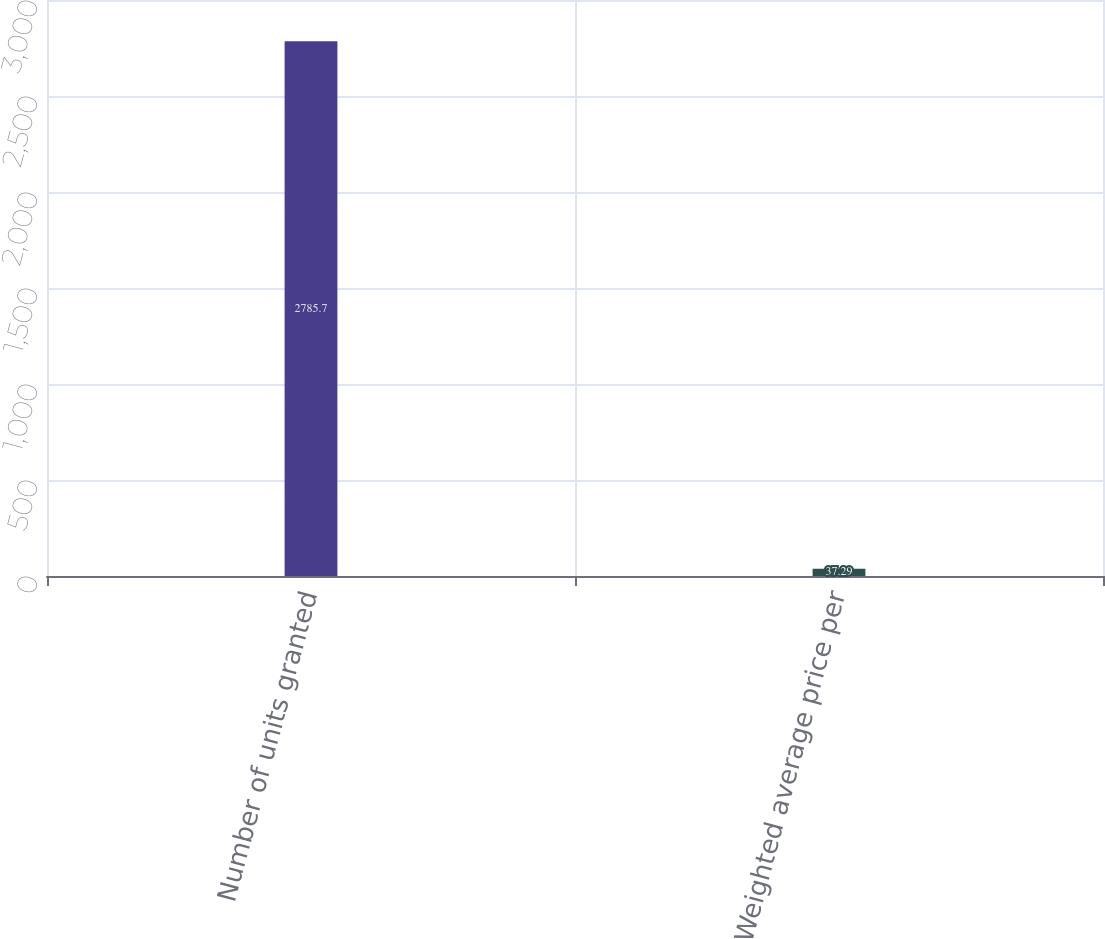Convert chart. <chart><loc_0><loc_0><loc_500><loc_500><bar_chart><fcel>Number of units granted<fcel>Weighted average price per<nl><fcel>2785.7<fcel>37.29<nl></chart> 